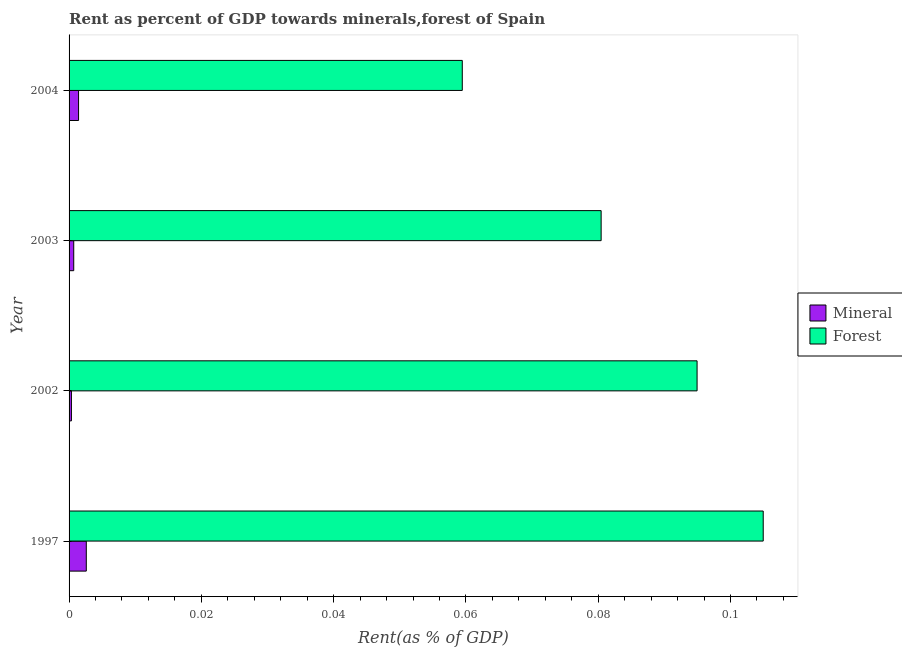How many different coloured bars are there?
Make the answer very short. 2. Are the number of bars per tick equal to the number of legend labels?
Ensure brevity in your answer.  Yes. In how many cases, is the number of bars for a given year not equal to the number of legend labels?
Your response must be concise. 0. What is the mineral rent in 2002?
Ensure brevity in your answer.  0. Across all years, what is the maximum forest rent?
Keep it short and to the point. 0.1. Across all years, what is the minimum mineral rent?
Ensure brevity in your answer.  0. In which year was the mineral rent minimum?
Your answer should be compact. 2002. What is the total forest rent in the graph?
Your answer should be very brief. 0.34. What is the difference between the forest rent in 2003 and that in 2004?
Keep it short and to the point. 0.02. What is the difference between the mineral rent in 2002 and the forest rent in 1997?
Provide a succinct answer. -0.1. In the year 2004, what is the difference between the mineral rent and forest rent?
Provide a short and direct response. -0.06. In how many years, is the mineral rent greater than 0.096 %?
Provide a short and direct response. 0. What is the ratio of the forest rent in 1997 to that in 2002?
Your answer should be compact. 1.1. Is the mineral rent in 1997 less than that in 2003?
Offer a terse response. No. What is the difference between the highest and the lowest mineral rent?
Provide a succinct answer. 0. Is the sum of the mineral rent in 1997 and 2002 greater than the maximum forest rent across all years?
Keep it short and to the point. No. What does the 2nd bar from the top in 1997 represents?
Your answer should be very brief. Mineral. What does the 2nd bar from the bottom in 2004 represents?
Give a very brief answer. Forest. How many bars are there?
Provide a succinct answer. 8. Are the values on the major ticks of X-axis written in scientific E-notation?
Make the answer very short. No. Does the graph contain any zero values?
Provide a succinct answer. No. Where does the legend appear in the graph?
Your answer should be very brief. Center right. How many legend labels are there?
Offer a terse response. 2. What is the title of the graph?
Provide a short and direct response. Rent as percent of GDP towards minerals,forest of Spain. Does "IMF nonconcessional" appear as one of the legend labels in the graph?
Provide a succinct answer. No. What is the label or title of the X-axis?
Your answer should be compact. Rent(as % of GDP). What is the label or title of the Y-axis?
Give a very brief answer. Year. What is the Rent(as % of GDP) of Mineral in 1997?
Your answer should be very brief. 0. What is the Rent(as % of GDP) in Forest in 1997?
Keep it short and to the point. 0.1. What is the Rent(as % of GDP) in Mineral in 2002?
Make the answer very short. 0. What is the Rent(as % of GDP) in Forest in 2002?
Ensure brevity in your answer.  0.09. What is the Rent(as % of GDP) of Mineral in 2003?
Make the answer very short. 0. What is the Rent(as % of GDP) of Forest in 2003?
Keep it short and to the point. 0.08. What is the Rent(as % of GDP) in Mineral in 2004?
Offer a very short reply. 0. What is the Rent(as % of GDP) in Forest in 2004?
Give a very brief answer. 0.06. Across all years, what is the maximum Rent(as % of GDP) of Mineral?
Your answer should be compact. 0. Across all years, what is the maximum Rent(as % of GDP) in Forest?
Keep it short and to the point. 0.1. Across all years, what is the minimum Rent(as % of GDP) in Mineral?
Your response must be concise. 0. Across all years, what is the minimum Rent(as % of GDP) in Forest?
Your answer should be very brief. 0.06. What is the total Rent(as % of GDP) in Mineral in the graph?
Make the answer very short. 0.01. What is the total Rent(as % of GDP) of Forest in the graph?
Provide a short and direct response. 0.34. What is the difference between the Rent(as % of GDP) of Mineral in 1997 and that in 2002?
Ensure brevity in your answer.  0. What is the difference between the Rent(as % of GDP) in Mineral in 1997 and that in 2003?
Your answer should be compact. 0. What is the difference between the Rent(as % of GDP) in Forest in 1997 and that in 2003?
Your response must be concise. 0.02. What is the difference between the Rent(as % of GDP) in Mineral in 1997 and that in 2004?
Ensure brevity in your answer.  0. What is the difference between the Rent(as % of GDP) of Forest in 1997 and that in 2004?
Provide a short and direct response. 0.05. What is the difference between the Rent(as % of GDP) in Mineral in 2002 and that in 2003?
Make the answer very short. -0. What is the difference between the Rent(as % of GDP) of Forest in 2002 and that in 2003?
Keep it short and to the point. 0.01. What is the difference between the Rent(as % of GDP) in Mineral in 2002 and that in 2004?
Provide a succinct answer. -0. What is the difference between the Rent(as % of GDP) of Forest in 2002 and that in 2004?
Provide a succinct answer. 0.04. What is the difference between the Rent(as % of GDP) in Mineral in 2003 and that in 2004?
Offer a terse response. -0. What is the difference between the Rent(as % of GDP) in Forest in 2003 and that in 2004?
Make the answer very short. 0.02. What is the difference between the Rent(as % of GDP) of Mineral in 1997 and the Rent(as % of GDP) of Forest in 2002?
Your response must be concise. -0.09. What is the difference between the Rent(as % of GDP) in Mineral in 1997 and the Rent(as % of GDP) in Forest in 2003?
Your response must be concise. -0.08. What is the difference between the Rent(as % of GDP) in Mineral in 1997 and the Rent(as % of GDP) in Forest in 2004?
Your response must be concise. -0.06. What is the difference between the Rent(as % of GDP) of Mineral in 2002 and the Rent(as % of GDP) of Forest in 2003?
Provide a short and direct response. -0.08. What is the difference between the Rent(as % of GDP) in Mineral in 2002 and the Rent(as % of GDP) in Forest in 2004?
Offer a very short reply. -0.06. What is the difference between the Rent(as % of GDP) in Mineral in 2003 and the Rent(as % of GDP) in Forest in 2004?
Your response must be concise. -0.06. What is the average Rent(as % of GDP) in Mineral per year?
Make the answer very short. 0. What is the average Rent(as % of GDP) in Forest per year?
Keep it short and to the point. 0.09. In the year 1997, what is the difference between the Rent(as % of GDP) of Mineral and Rent(as % of GDP) of Forest?
Provide a short and direct response. -0.1. In the year 2002, what is the difference between the Rent(as % of GDP) in Mineral and Rent(as % of GDP) in Forest?
Offer a terse response. -0.09. In the year 2003, what is the difference between the Rent(as % of GDP) in Mineral and Rent(as % of GDP) in Forest?
Offer a terse response. -0.08. In the year 2004, what is the difference between the Rent(as % of GDP) in Mineral and Rent(as % of GDP) in Forest?
Keep it short and to the point. -0.06. What is the ratio of the Rent(as % of GDP) of Mineral in 1997 to that in 2002?
Provide a succinct answer. 7.33. What is the ratio of the Rent(as % of GDP) in Forest in 1997 to that in 2002?
Give a very brief answer. 1.11. What is the ratio of the Rent(as % of GDP) in Mineral in 1997 to that in 2003?
Provide a short and direct response. 3.7. What is the ratio of the Rent(as % of GDP) in Forest in 1997 to that in 2003?
Your response must be concise. 1.3. What is the ratio of the Rent(as % of GDP) of Mineral in 1997 to that in 2004?
Provide a succinct answer. 1.81. What is the ratio of the Rent(as % of GDP) in Forest in 1997 to that in 2004?
Your answer should be very brief. 1.77. What is the ratio of the Rent(as % of GDP) in Mineral in 2002 to that in 2003?
Give a very brief answer. 0.5. What is the ratio of the Rent(as % of GDP) in Forest in 2002 to that in 2003?
Offer a terse response. 1.18. What is the ratio of the Rent(as % of GDP) of Mineral in 2002 to that in 2004?
Provide a succinct answer. 0.25. What is the ratio of the Rent(as % of GDP) of Forest in 2002 to that in 2004?
Your response must be concise. 1.6. What is the ratio of the Rent(as % of GDP) in Mineral in 2003 to that in 2004?
Keep it short and to the point. 0.49. What is the ratio of the Rent(as % of GDP) in Forest in 2003 to that in 2004?
Your response must be concise. 1.35. What is the difference between the highest and the second highest Rent(as % of GDP) in Mineral?
Your response must be concise. 0. What is the difference between the highest and the second highest Rent(as % of GDP) of Forest?
Your response must be concise. 0.01. What is the difference between the highest and the lowest Rent(as % of GDP) of Mineral?
Offer a very short reply. 0. What is the difference between the highest and the lowest Rent(as % of GDP) of Forest?
Ensure brevity in your answer.  0.05. 